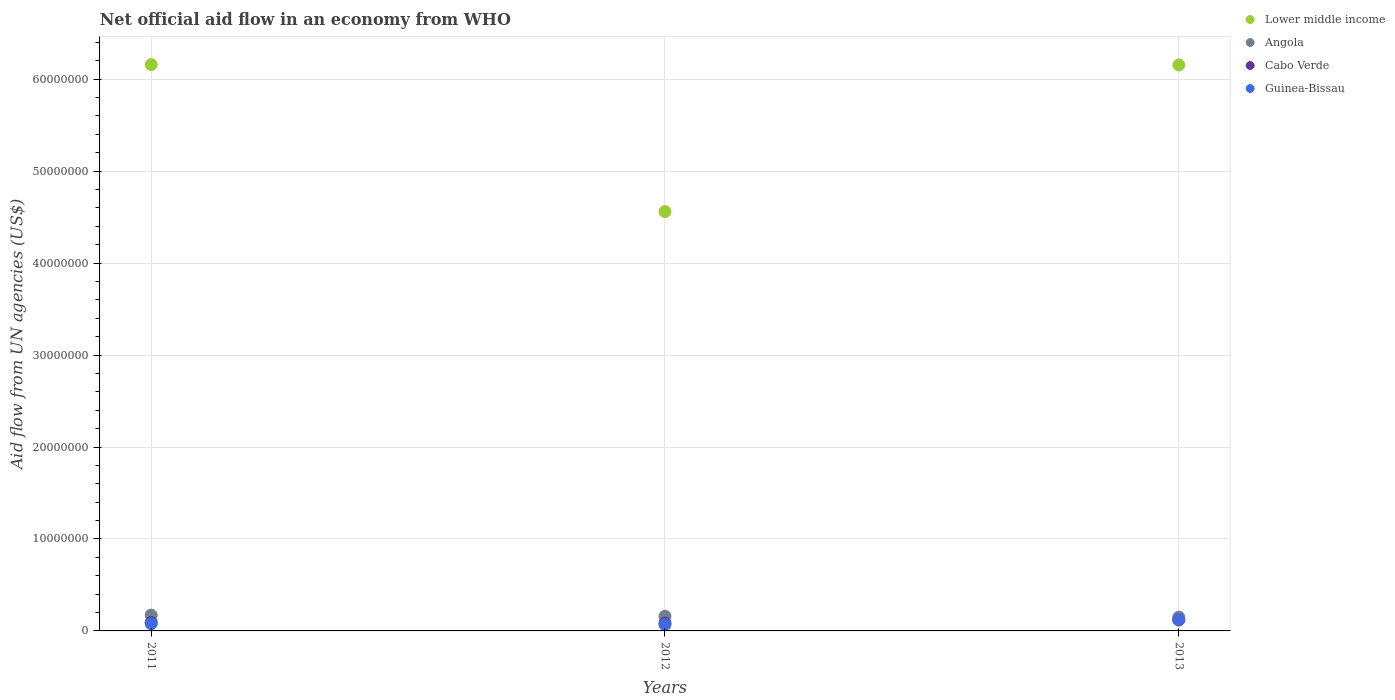Is the number of dotlines equal to the number of legend labels?
Keep it short and to the point. Yes. What is the net official aid flow in Angola in 2013?
Make the answer very short. 1.50e+06. Across all years, what is the maximum net official aid flow in Guinea-Bissau?
Your answer should be compact. 1.23e+06. Across all years, what is the minimum net official aid flow in Cabo Verde?
Offer a very short reply. 8.50e+05. In which year was the net official aid flow in Lower middle income maximum?
Give a very brief answer. 2011. In which year was the net official aid flow in Lower middle income minimum?
Your response must be concise. 2012. What is the total net official aid flow in Lower middle income in the graph?
Your answer should be compact. 1.69e+08. What is the difference between the net official aid flow in Cabo Verde in 2011 and the net official aid flow in Angola in 2012?
Your answer should be very brief. -6.60e+05. What is the average net official aid flow in Guinea-Bissau per year?
Offer a very short reply. 9.07e+05. In the year 2011, what is the difference between the net official aid flow in Cabo Verde and net official aid flow in Guinea-Bissau?
Ensure brevity in your answer.  1.40e+05. In how many years, is the net official aid flow in Guinea-Bissau greater than 46000000 US$?
Keep it short and to the point. 0. What is the ratio of the net official aid flow in Angola in 2012 to that in 2013?
Keep it short and to the point. 1.06. Is the net official aid flow in Angola in 2011 less than that in 2012?
Give a very brief answer. No. What is the difference between the highest and the lowest net official aid flow in Guinea-Bissau?
Your answer should be compact. 5.30e+05. In how many years, is the net official aid flow in Lower middle income greater than the average net official aid flow in Lower middle income taken over all years?
Your answer should be compact. 2. Does the net official aid flow in Angola monotonically increase over the years?
Provide a succinct answer. No. Is the net official aid flow in Guinea-Bissau strictly greater than the net official aid flow in Lower middle income over the years?
Offer a terse response. No. Is the net official aid flow in Guinea-Bissau strictly less than the net official aid flow in Lower middle income over the years?
Provide a succinct answer. Yes. How many dotlines are there?
Your answer should be very brief. 4. How many years are there in the graph?
Your response must be concise. 3. What is the difference between two consecutive major ticks on the Y-axis?
Offer a terse response. 1.00e+07. Are the values on the major ticks of Y-axis written in scientific E-notation?
Your answer should be very brief. No. Does the graph contain any zero values?
Make the answer very short. No. Does the graph contain grids?
Provide a succinct answer. Yes. How many legend labels are there?
Give a very brief answer. 4. How are the legend labels stacked?
Make the answer very short. Vertical. What is the title of the graph?
Your response must be concise. Net official aid flow in an economy from WHO. What is the label or title of the X-axis?
Give a very brief answer. Years. What is the label or title of the Y-axis?
Give a very brief answer. Aid flow from UN agencies (US$). What is the Aid flow from UN agencies (US$) in Lower middle income in 2011?
Provide a succinct answer. 6.16e+07. What is the Aid flow from UN agencies (US$) of Angola in 2011?
Keep it short and to the point. 1.72e+06. What is the Aid flow from UN agencies (US$) in Cabo Verde in 2011?
Offer a very short reply. 9.30e+05. What is the Aid flow from UN agencies (US$) of Guinea-Bissau in 2011?
Keep it short and to the point. 7.90e+05. What is the Aid flow from UN agencies (US$) in Lower middle income in 2012?
Your answer should be compact. 4.56e+07. What is the Aid flow from UN agencies (US$) of Angola in 2012?
Offer a terse response. 1.59e+06. What is the Aid flow from UN agencies (US$) of Cabo Verde in 2012?
Give a very brief answer. 8.50e+05. What is the Aid flow from UN agencies (US$) in Lower middle income in 2013?
Ensure brevity in your answer.  6.16e+07. What is the Aid flow from UN agencies (US$) in Angola in 2013?
Offer a terse response. 1.50e+06. What is the Aid flow from UN agencies (US$) in Cabo Verde in 2013?
Your response must be concise. 1.19e+06. What is the Aid flow from UN agencies (US$) in Guinea-Bissau in 2013?
Provide a succinct answer. 1.23e+06. Across all years, what is the maximum Aid flow from UN agencies (US$) in Lower middle income?
Ensure brevity in your answer.  6.16e+07. Across all years, what is the maximum Aid flow from UN agencies (US$) of Angola?
Make the answer very short. 1.72e+06. Across all years, what is the maximum Aid flow from UN agencies (US$) of Cabo Verde?
Provide a succinct answer. 1.19e+06. Across all years, what is the maximum Aid flow from UN agencies (US$) of Guinea-Bissau?
Give a very brief answer. 1.23e+06. Across all years, what is the minimum Aid flow from UN agencies (US$) of Lower middle income?
Your response must be concise. 4.56e+07. Across all years, what is the minimum Aid flow from UN agencies (US$) of Angola?
Keep it short and to the point. 1.50e+06. Across all years, what is the minimum Aid flow from UN agencies (US$) in Cabo Verde?
Your answer should be very brief. 8.50e+05. Across all years, what is the minimum Aid flow from UN agencies (US$) in Guinea-Bissau?
Your response must be concise. 7.00e+05. What is the total Aid flow from UN agencies (US$) of Lower middle income in the graph?
Ensure brevity in your answer.  1.69e+08. What is the total Aid flow from UN agencies (US$) in Angola in the graph?
Ensure brevity in your answer.  4.81e+06. What is the total Aid flow from UN agencies (US$) of Cabo Verde in the graph?
Your answer should be compact. 2.97e+06. What is the total Aid flow from UN agencies (US$) of Guinea-Bissau in the graph?
Offer a terse response. 2.72e+06. What is the difference between the Aid flow from UN agencies (US$) of Lower middle income in 2011 and that in 2012?
Offer a very short reply. 1.60e+07. What is the difference between the Aid flow from UN agencies (US$) in Angola in 2011 and that in 2012?
Keep it short and to the point. 1.30e+05. What is the difference between the Aid flow from UN agencies (US$) in Cabo Verde in 2011 and that in 2012?
Your response must be concise. 8.00e+04. What is the difference between the Aid flow from UN agencies (US$) of Lower middle income in 2011 and that in 2013?
Make the answer very short. 4.00e+04. What is the difference between the Aid flow from UN agencies (US$) of Angola in 2011 and that in 2013?
Your response must be concise. 2.20e+05. What is the difference between the Aid flow from UN agencies (US$) in Guinea-Bissau in 2011 and that in 2013?
Offer a terse response. -4.40e+05. What is the difference between the Aid flow from UN agencies (US$) of Lower middle income in 2012 and that in 2013?
Offer a very short reply. -1.60e+07. What is the difference between the Aid flow from UN agencies (US$) of Angola in 2012 and that in 2013?
Your answer should be compact. 9.00e+04. What is the difference between the Aid flow from UN agencies (US$) in Cabo Verde in 2012 and that in 2013?
Provide a succinct answer. -3.40e+05. What is the difference between the Aid flow from UN agencies (US$) of Guinea-Bissau in 2012 and that in 2013?
Offer a terse response. -5.30e+05. What is the difference between the Aid flow from UN agencies (US$) in Lower middle income in 2011 and the Aid flow from UN agencies (US$) in Angola in 2012?
Make the answer very short. 6.00e+07. What is the difference between the Aid flow from UN agencies (US$) of Lower middle income in 2011 and the Aid flow from UN agencies (US$) of Cabo Verde in 2012?
Ensure brevity in your answer.  6.07e+07. What is the difference between the Aid flow from UN agencies (US$) in Lower middle income in 2011 and the Aid flow from UN agencies (US$) in Guinea-Bissau in 2012?
Your answer should be compact. 6.09e+07. What is the difference between the Aid flow from UN agencies (US$) in Angola in 2011 and the Aid flow from UN agencies (US$) in Cabo Verde in 2012?
Your answer should be compact. 8.70e+05. What is the difference between the Aid flow from UN agencies (US$) in Angola in 2011 and the Aid flow from UN agencies (US$) in Guinea-Bissau in 2012?
Offer a very short reply. 1.02e+06. What is the difference between the Aid flow from UN agencies (US$) of Lower middle income in 2011 and the Aid flow from UN agencies (US$) of Angola in 2013?
Ensure brevity in your answer.  6.01e+07. What is the difference between the Aid flow from UN agencies (US$) in Lower middle income in 2011 and the Aid flow from UN agencies (US$) in Cabo Verde in 2013?
Provide a short and direct response. 6.04e+07. What is the difference between the Aid flow from UN agencies (US$) in Lower middle income in 2011 and the Aid flow from UN agencies (US$) in Guinea-Bissau in 2013?
Provide a succinct answer. 6.04e+07. What is the difference between the Aid flow from UN agencies (US$) of Angola in 2011 and the Aid flow from UN agencies (US$) of Cabo Verde in 2013?
Give a very brief answer. 5.30e+05. What is the difference between the Aid flow from UN agencies (US$) in Angola in 2011 and the Aid flow from UN agencies (US$) in Guinea-Bissau in 2013?
Your response must be concise. 4.90e+05. What is the difference between the Aid flow from UN agencies (US$) in Lower middle income in 2012 and the Aid flow from UN agencies (US$) in Angola in 2013?
Keep it short and to the point. 4.41e+07. What is the difference between the Aid flow from UN agencies (US$) of Lower middle income in 2012 and the Aid flow from UN agencies (US$) of Cabo Verde in 2013?
Ensure brevity in your answer.  4.44e+07. What is the difference between the Aid flow from UN agencies (US$) of Lower middle income in 2012 and the Aid flow from UN agencies (US$) of Guinea-Bissau in 2013?
Ensure brevity in your answer.  4.44e+07. What is the difference between the Aid flow from UN agencies (US$) in Angola in 2012 and the Aid flow from UN agencies (US$) in Guinea-Bissau in 2013?
Offer a very short reply. 3.60e+05. What is the difference between the Aid flow from UN agencies (US$) in Cabo Verde in 2012 and the Aid flow from UN agencies (US$) in Guinea-Bissau in 2013?
Provide a short and direct response. -3.80e+05. What is the average Aid flow from UN agencies (US$) of Lower middle income per year?
Your answer should be compact. 5.62e+07. What is the average Aid flow from UN agencies (US$) in Angola per year?
Ensure brevity in your answer.  1.60e+06. What is the average Aid flow from UN agencies (US$) of Cabo Verde per year?
Offer a terse response. 9.90e+05. What is the average Aid flow from UN agencies (US$) of Guinea-Bissau per year?
Offer a terse response. 9.07e+05. In the year 2011, what is the difference between the Aid flow from UN agencies (US$) of Lower middle income and Aid flow from UN agencies (US$) of Angola?
Your response must be concise. 5.99e+07. In the year 2011, what is the difference between the Aid flow from UN agencies (US$) of Lower middle income and Aid flow from UN agencies (US$) of Cabo Verde?
Offer a terse response. 6.07e+07. In the year 2011, what is the difference between the Aid flow from UN agencies (US$) in Lower middle income and Aid flow from UN agencies (US$) in Guinea-Bissau?
Your answer should be very brief. 6.08e+07. In the year 2011, what is the difference between the Aid flow from UN agencies (US$) in Angola and Aid flow from UN agencies (US$) in Cabo Verde?
Your response must be concise. 7.90e+05. In the year 2011, what is the difference between the Aid flow from UN agencies (US$) of Angola and Aid flow from UN agencies (US$) of Guinea-Bissau?
Offer a very short reply. 9.30e+05. In the year 2012, what is the difference between the Aid flow from UN agencies (US$) of Lower middle income and Aid flow from UN agencies (US$) of Angola?
Your response must be concise. 4.40e+07. In the year 2012, what is the difference between the Aid flow from UN agencies (US$) of Lower middle income and Aid flow from UN agencies (US$) of Cabo Verde?
Offer a very short reply. 4.48e+07. In the year 2012, what is the difference between the Aid flow from UN agencies (US$) of Lower middle income and Aid flow from UN agencies (US$) of Guinea-Bissau?
Offer a terse response. 4.49e+07. In the year 2012, what is the difference between the Aid flow from UN agencies (US$) in Angola and Aid flow from UN agencies (US$) in Cabo Verde?
Give a very brief answer. 7.40e+05. In the year 2012, what is the difference between the Aid flow from UN agencies (US$) in Angola and Aid flow from UN agencies (US$) in Guinea-Bissau?
Your answer should be very brief. 8.90e+05. In the year 2012, what is the difference between the Aid flow from UN agencies (US$) in Cabo Verde and Aid flow from UN agencies (US$) in Guinea-Bissau?
Your answer should be very brief. 1.50e+05. In the year 2013, what is the difference between the Aid flow from UN agencies (US$) in Lower middle income and Aid flow from UN agencies (US$) in Angola?
Keep it short and to the point. 6.00e+07. In the year 2013, what is the difference between the Aid flow from UN agencies (US$) of Lower middle income and Aid flow from UN agencies (US$) of Cabo Verde?
Provide a succinct answer. 6.04e+07. In the year 2013, what is the difference between the Aid flow from UN agencies (US$) in Lower middle income and Aid flow from UN agencies (US$) in Guinea-Bissau?
Your answer should be compact. 6.03e+07. In the year 2013, what is the difference between the Aid flow from UN agencies (US$) in Angola and Aid flow from UN agencies (US$) in Cabo Verde?
Ensure brevity in your answer.  3.10e+05. In the year 2013, what is the difference between the Aid flow from UN agencies (US$) in Cabo Verde and Aid flow from UN agencies (US$) in Guinea-Bissau?
Provide a short and direct response. -4.00e+04. What is the ratio of the Aid flow from UN agencies (US$) in Lower middle income in 2011 to that in 2012?
Your response must be concise. 1.35. What is the ratio of the Aid flow from UN agencies (US$) of Angola in 2011 to that in 2012?
Your answer should be compact. 1.08. What is the ratio of the Aid flow from UN agencies (US$) of Cabo Verde in 2011 to that in 2012?
Your response must be concise. 1.09. What is the ratio of the Aid flow from UN agencies (US$) of Guinea-Bissau in 2011 to that in 2012?
Your answer should be very brief. 1.13. What is the ratio of the Aid flow from UN agencies (US$) in Angola in 2011 to that in 2013?
Offer a very short reply. 1.15. What is the ratio of the Aid flow from UN agencies (US$) of Cabo Verde in 2011 to that in 2013?
Your answer should be very brief. 0.78. What is the ratio of the Aid flow from UN agencies (US$) of Guinea-Bissau in 2011 to that in 2013?
Ensure brevity in your answer.  0.64. What is the ratio of the Aid flow from UN agencies (US$) in Lower middle income in 2012 to that in 2013?
Keep it short and to the point. 0.74. What is the ratio of the Aid flow from UN agencies (US$) of Angola in 2012 to that in 2013?
Ensure brevity in your answer.  1.06. What is the ratio of the Aid flow from UN agencies (US$) in Guinea-Bissau in 2012 to that in 2013?
Offer a very short reply. 0.57. What is the difference between the highest and the second highest Aid flow from UN agencies (US$) of Angola?
Offer a very short reply. 1.30e+05. What is the difference between the highest and the lowest Aid flow from UN agencies (US$) of Lower middle income?
Provide a succinct answer. 1.60e+07. What is the difference between the highest and the lowest Aid flow from UN agencies (US$) in Angola?
Offer a very short reply. 2.20e+05. What is the difference between the highest and the lowest Aid flow from UN agencies (US$) of Cabo Verde?
Provide a short and direct response. 3.40e+05. What is the difference between the highest and the lowest Aid flow from UN agencies (US$) of Guinea-Bissau?
Provide a succinct answer. 5.30e+05. 